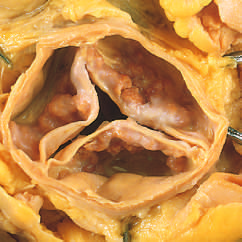re small nests of epithelial cells and myxoid stroma forming cartilage and bone heaped up within the sinuses of valsalva?
Answer the question using a single word or phrase. No 